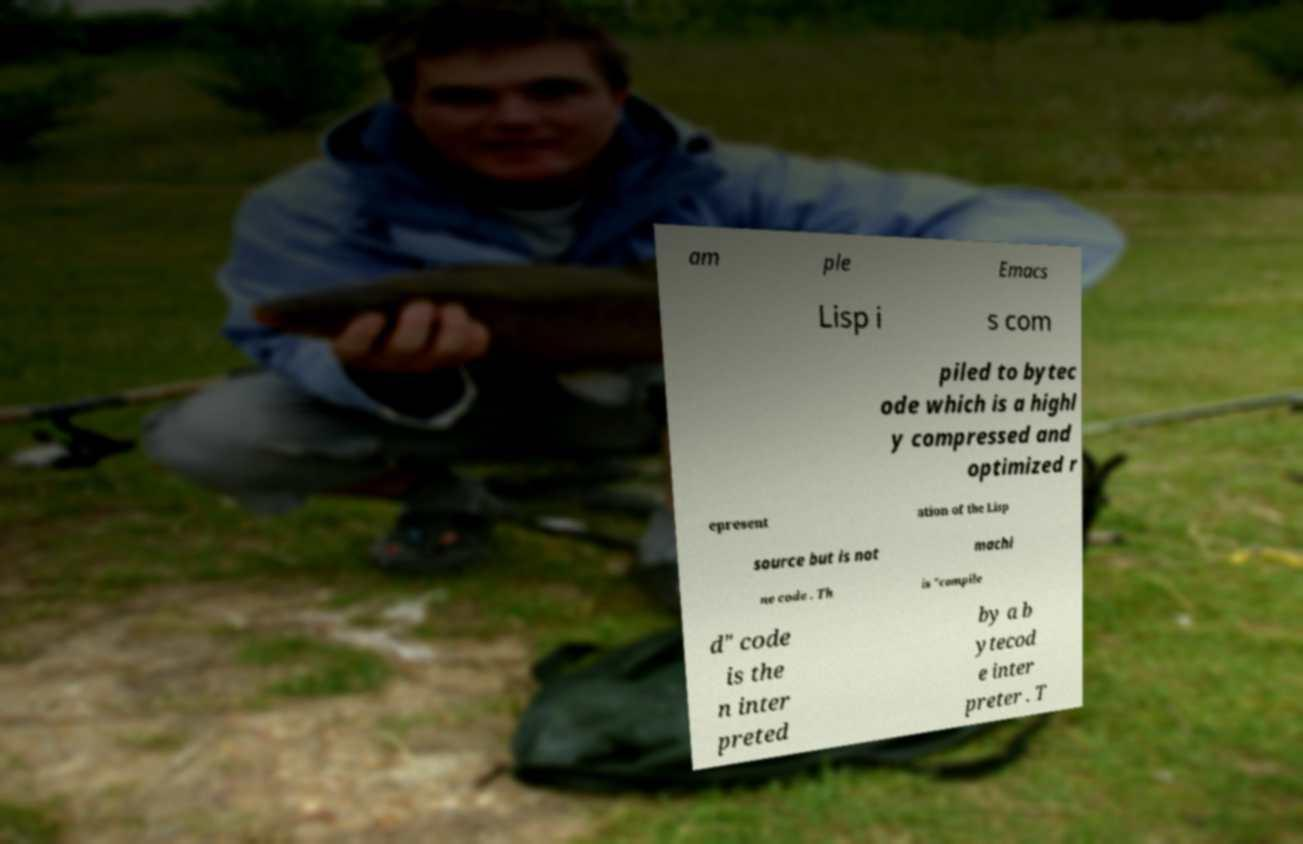Please identify and transcribe the text found in this image. am ple Emacs Lisp i s com piled to bytec ode which is a highl y compressed and optimized r epresent ation of the Lisp source but is not machi ne code . Th is "compile d" code is the n inter preted by a b ytecod e inter preter . T 